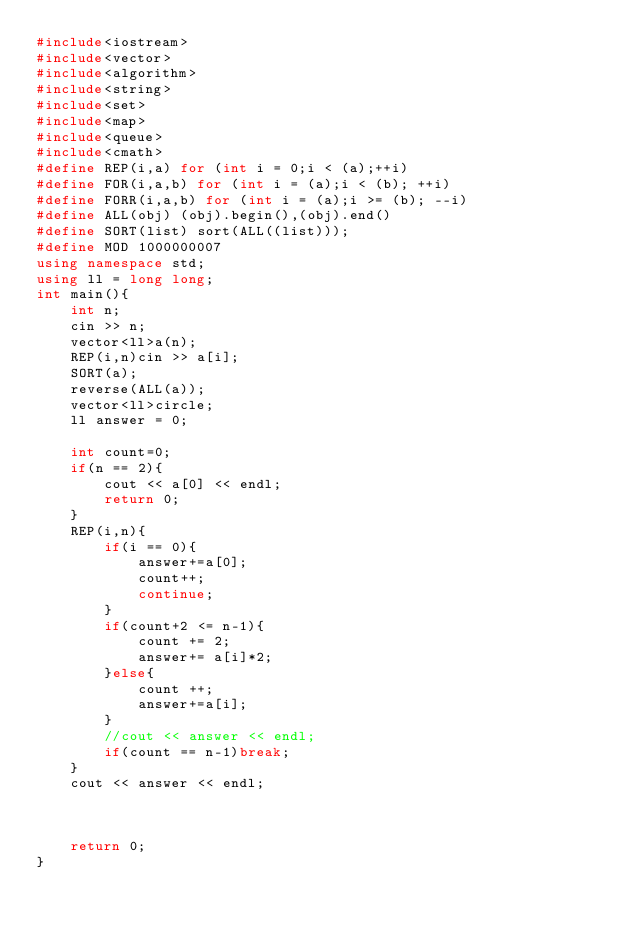Convert code to text. <code><loc_0><loc_0><loc_500><loc_500><_C++_>#include<iostream>
#include<vector>
#include<algorithm>
#include<string>
#include<set>
#include<map>
#include<queue>
#include<cmath>
#define REP(i,a) for (int i = 0;i < (a);++i)
#define FOR(i,a,b) for (int i = (a);i < (b); ++i)
#define FORR(i,a,b) for (int i = (a);i >= (b); --i)
#define ALL(obj) (obj).begin(),(obj).end()
#define SORT(list) sort(ALL((list)));
#define MOD 1000000007
using namespace std;
using ll = long long;
int main(){
    int n;
    cin >> n;
    vector<ll>a(n);
    REP(i,n)cin >> a[i];
    SORT(a);
    reverse(ALL(a));
    vector<ll>circle;
    ll answer = 0;
    
    int count=0;
    if(n == 2){
        cout << a[0] << endl;
        return 0;
    }
    REP(i,n){
        if(i == 0){
            answer+=a[0];
            count++;
            continue;
        }
        if(count+2 <= n-1){
            count += 2;
            answer+= a[i]*2;
        }else{
            count ++;
            answer+=a[i];
        }
        //cout << answer << endl;
        if(count == n-1)break;
    }
    cout << answer << endl;


    
    return 0;
}</code> 